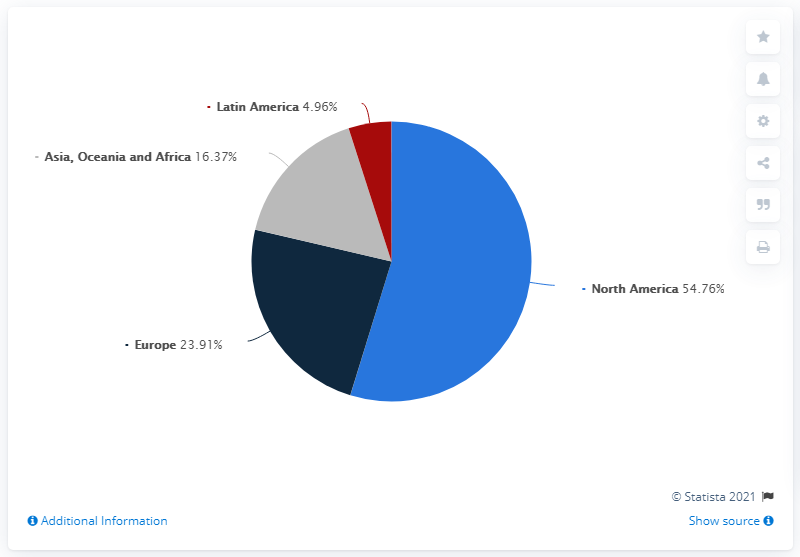List a handful of essential elements in this visual. The average of Europe and North America is 39.3. The color red is often associated with Latin America. 